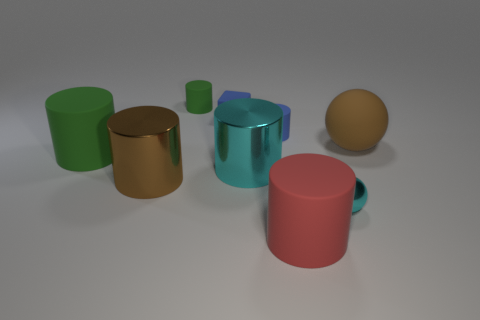Can you describe the texture and finish of the objects in the image? Sure, the objects in the image have a smooth surface with different finishes. The golden cylinder and the sphere exhibit a metallic finish with a reflective quality that catches the light. The green cylinder, teal cup with a handle, and pink cup appear to have a matte finish with soft reflections, indicating a non-metallic texture. 